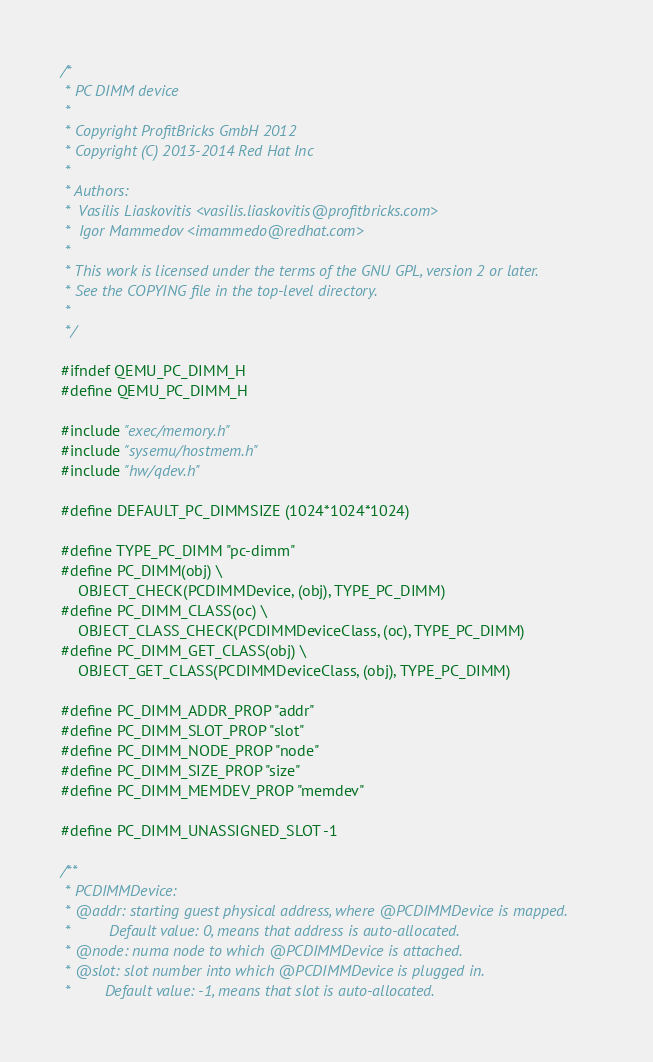<code> <loc_0><loc_0><loc_500><loc_500><_C_>/*
 * PC DIMM device
 *
 * Copyright ProfitBricks GmbH 2012
 * Copyright (C) 2013-2014 Red Hat Inc
 *
 * Authors:
 *  Vasilis Liaskovitis <vasilis.liaskovitis@profitbricks.com>
 *  Igor Mammedov <imammedo@redhat.com>
 *
 * This work is licensed under the terms of the GNU GPL, version 2 or later.
 * See the COPYING file in the top-level directory.
 *
 */

#ifndef QEMU_PC_DIMM_H
#define QEMU_PC_DIMM_H

#include "exec/memory.h"
#include "sysemu/hostmem.h"
#include "hw/qdev.h"

#define DEFAULT_PC_DIMMSIZE (1024*1024*1024)

#define TYPE_PC_DIMM "pc-dimm"
#define PC_DIMM(obj) \
    OBJECT_CHECK(PCDIMMDevice, (obj), TYPE_PC_DIMM)
#define PC_DIMM_CLASS(oc) \
    OBJECT_CLASS_CHECK(PCDIMMDeviceClass, (oc), TYPE_PC_DIMM)
#define PC_DIMM_GET_CLASS(obj) \
    OBJECT_GET_CLASS(PCDIMMDeviceClass, (obj), TYPE_PC_DIMM)

#define PC_DIMM_ADDR_PROP "addr"
#define PC_DIMM_SLOT_PROP "slot"
#define PC_DIMM_NODE_PROP "node"
#define PC_DIMM_SIZE_PROP "size"
#define PC_DIMM_MEMDEV_PROP "memdev"

#define PC_DIMM_UNASSIGNED_SLOT -1

/**
 * PCDIMMDevice:
 * @addr: starting guest physical address, where @PCDIMMDevice is mapped.
 *         Default value: 0, means that address is auto-allocated.
 * @node: numa node to which @PCDIMMDevice is attached.
 * @slot: slot number into which @PCDIMMDevice is plugged in.
 *        Default value: -1, means that slot is auto-allocated.</code> 